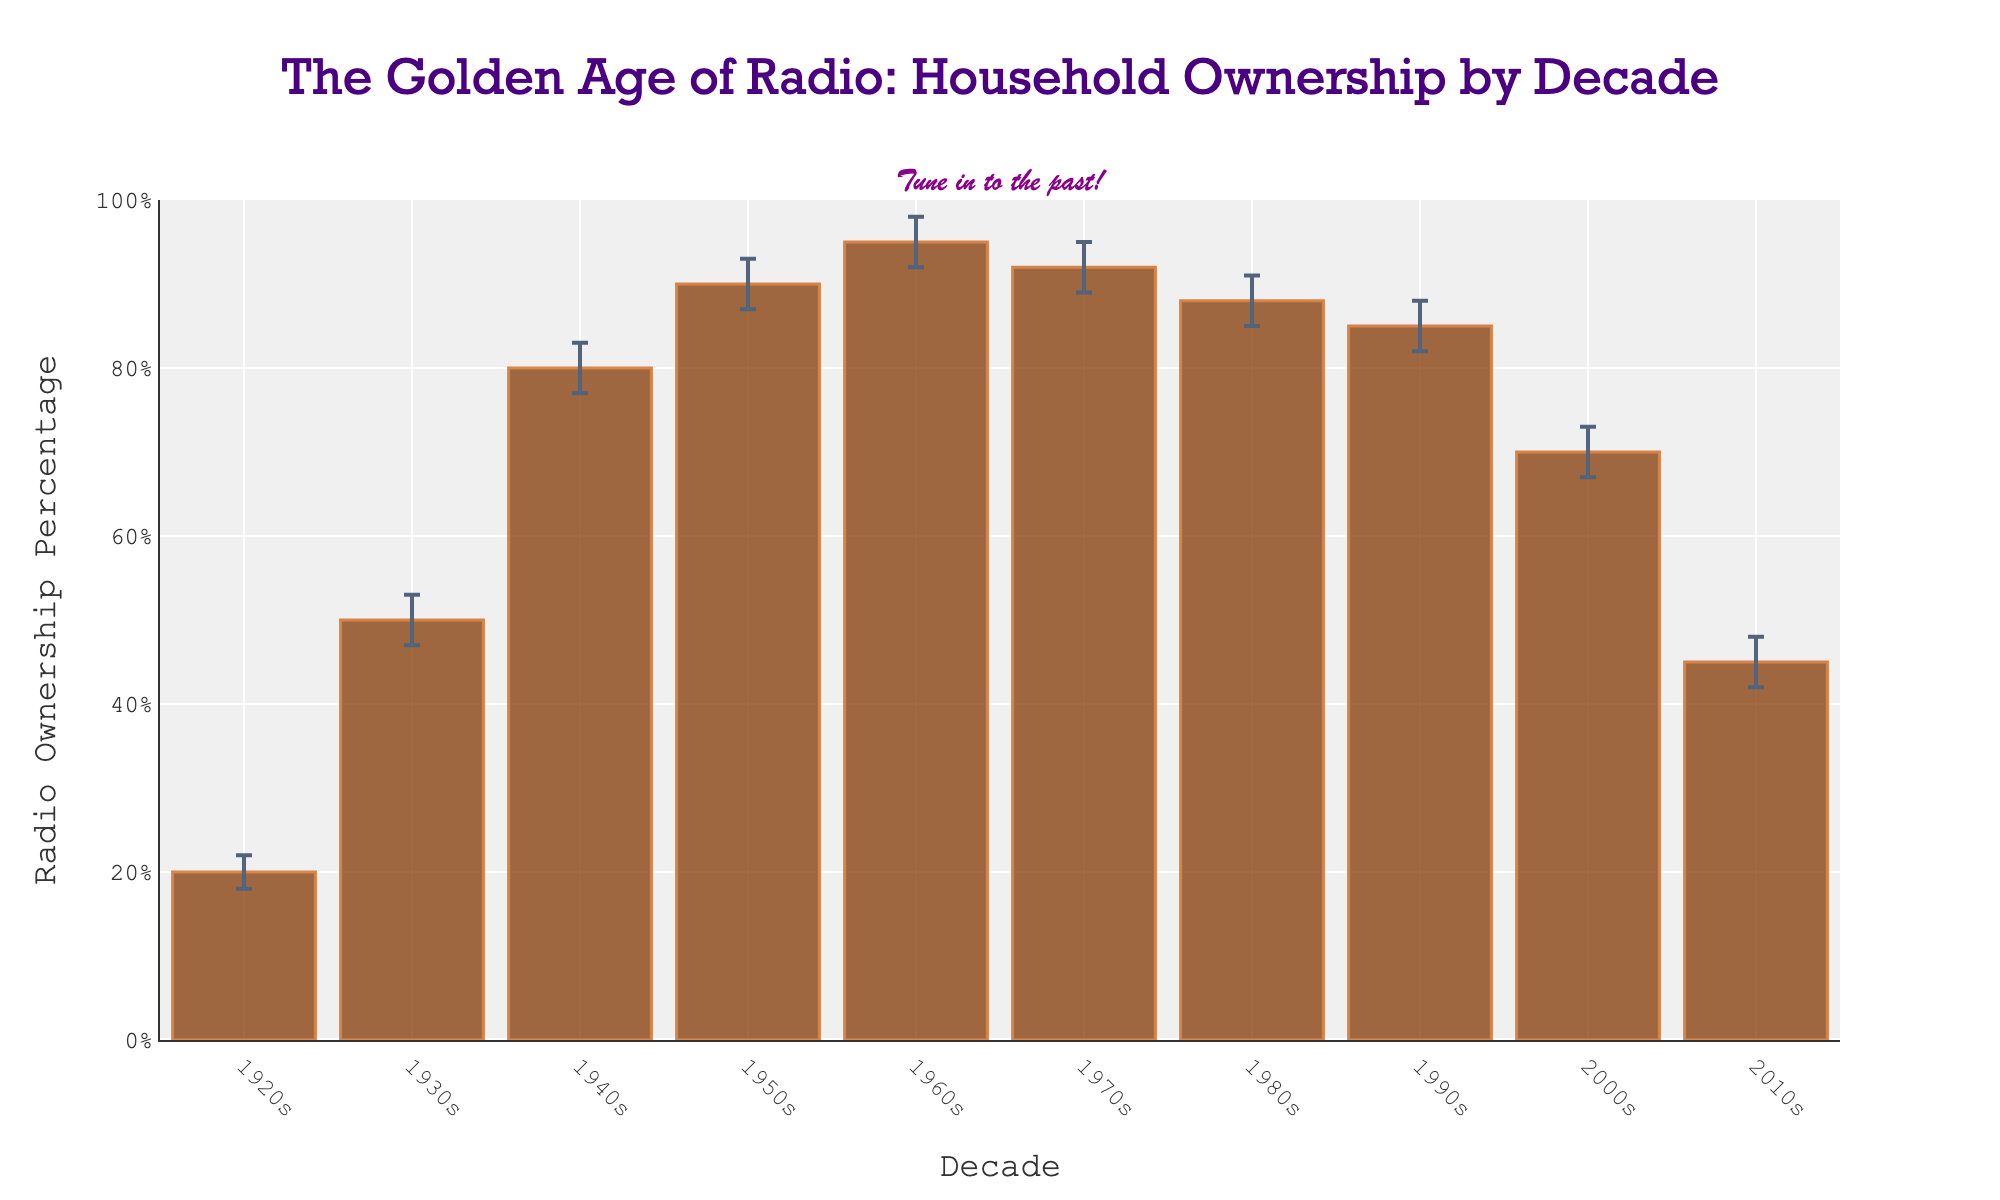What's the title of the figure? Look at the top of the figure where the title is displayed in larger text.
Answer: The Golden Age of Radio: Household Ownership by Decade What decade had the highest percentage of radio ownership? Identify the tallest bar in the figure which represents the highest percentage.
Answer: 1960s What is the range of radio ownership percentages across all decades? Calculate the difference between the maximum and minimum percentage values. Maximum is 95% (1960s) and minimum is 20% (1920s); the range is 95 - 20.
Answer: 75% Which decade experienced the largest increase in radio ownership percentage compared to its previous decade? Compute the increase by subtracting the percentages of each previous decade and find the largest. 1930s-1920s (50-20=30), 1940s-1930s (80-50=30), 1950s-1940s (90-80=10), 1960s-1950s (95-90=5), 1970s-1960s (-3), 1980s-1970s (-4), 1990s-1980s (-3), 2000s-1990s (-15), 2010s-2000s (-25). Largest increase is from 1920s to 1930s with an increase of 30.
Answer: 1930s In which decade did the radio ownership percentage begin to decline? Scan the bars to determine the first decade when the next bar is shorter than the current one. The first decline is from 1960s (95%) to 1970s (92%).
Answer: 1970s What is the confidence interval range for the 1940s? Identify the upper and lower values of the confidence interval for the 1940s and calculate the range: 83% (max) - 77% (min).
Answer: 6% What was the radio ownership percentage in the 2000s, and what were the confidence interval bounds? Locate the bar representing the 2000s and note the percentage and the confidence interval bounds: percentage is 70%, minimum is 67%, maximum is 73%.
Answer: 70%, 67-73% How does the radio ownership percentage in the 1990s compare to the 2010s? Compare the height of the bars for the 1990s and 2010s: 1990s is 85% and 2010s is 45%.
Answer: 1990s is higher During which decades did the confidence interval ranges overlap meaning radio ownership percentages were statistically similar? Check for overlaps in the error bars, which means the confidence interval ranges intersect: 1940s (77-83%) and 1950s (87-93%) do not overlap. 1950s (87-93%) and 1960s (92-98%) do overlap. Therefore, 1950s and 1960s are statistically similar.
Answer: 1950s and 1960s How many decades are represented in the figure? Count the number of bars in the graph, each representing one decade.
Answer: 10 